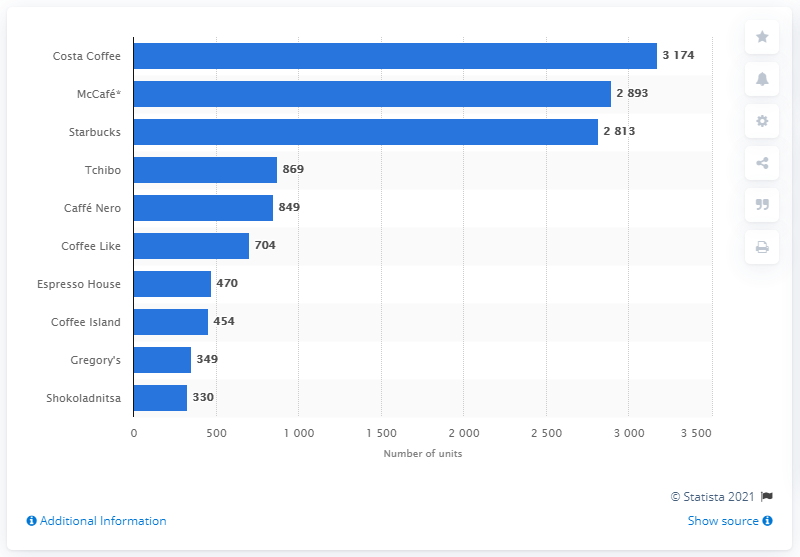Identify some key points in this picture. Costa Coffee was the leading coffeehouse brand in Europe in 2019. 